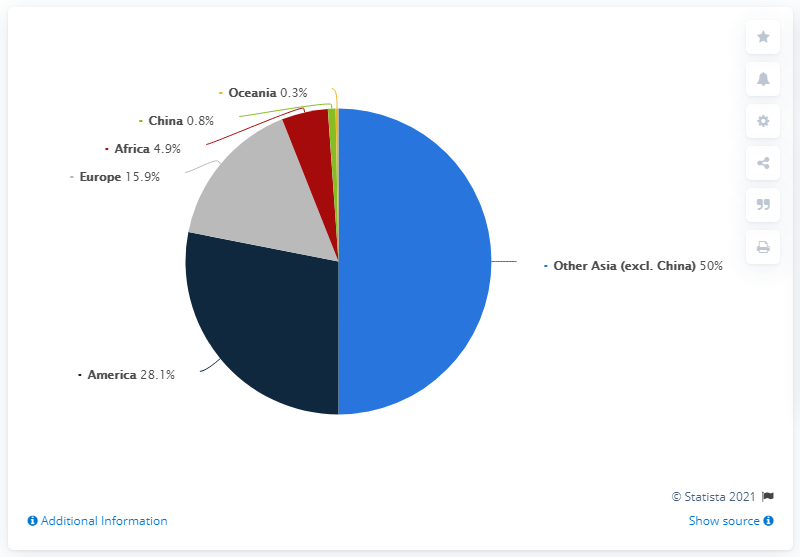List a handful of essential elements in this visual. The combined percentage of cases from Europe and America is 44%. In terms of contributing the most cases, America is the country to consider. 